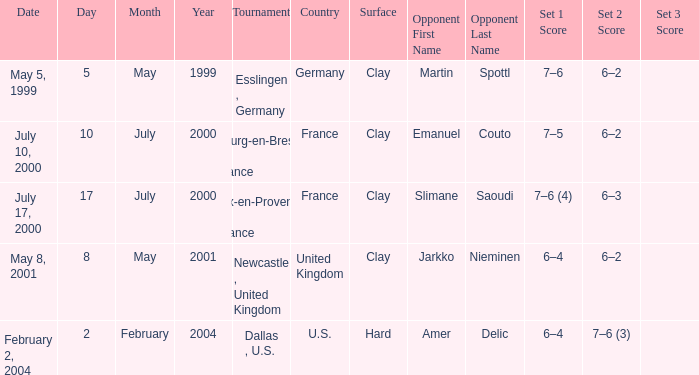What is the Opponent in the final of the game on february 2, 2004? Amer Delic. 